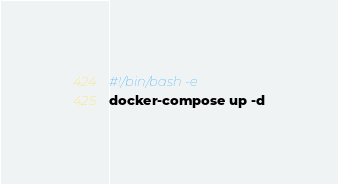Convert code to text. <code><loc_0><loc_0><loc_500><loc_500><_Bash_>#!/bin/bash -e
docker-compose up -d
</code> 